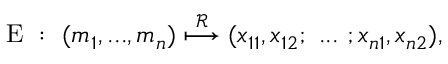<formula> <loc_0><loc_0><loc_500><loc_500>\begin{array} { r } { E \colon ( m _ { 1 } , \dots , m _ { n } ) \overset { \mathcal { R } } { \longmapsto } ( x _ { 1 1 } , x _ { 1 2 } ; \dots ; x _ { n 1 } , x _ { n 2 } ) , } \end{array}</formula> 